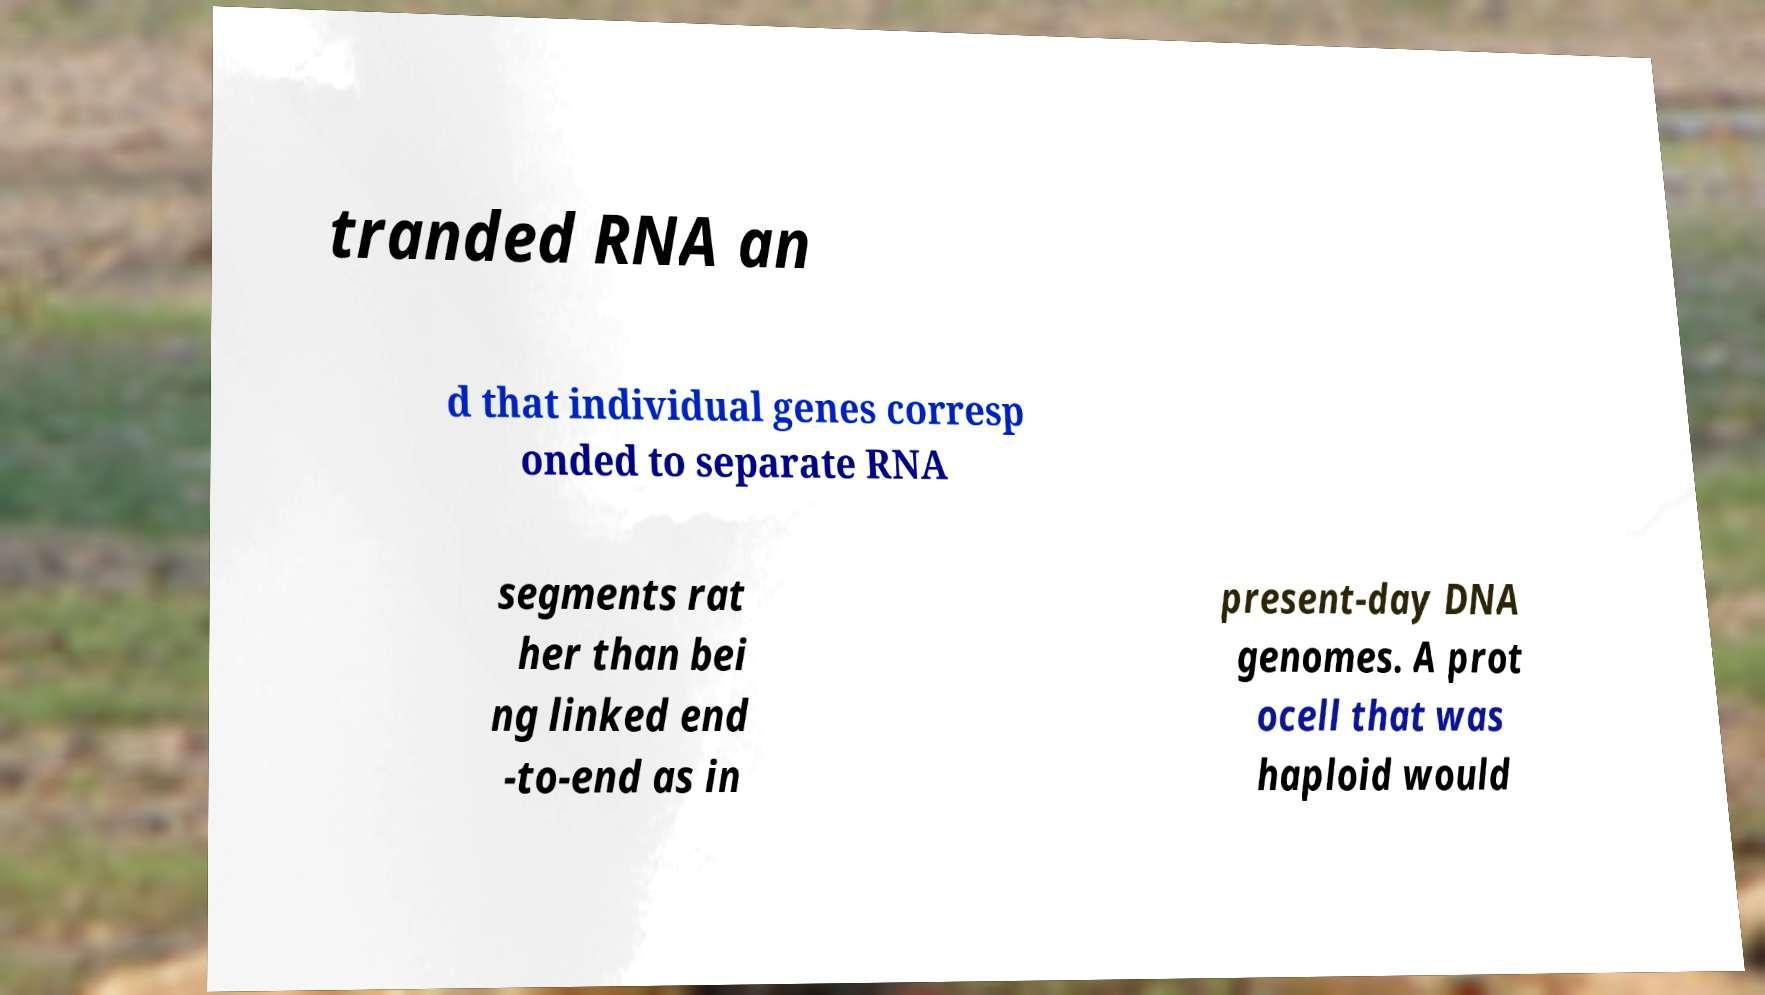Could you extract and type out the text from this image? tranded RNA an d that individual genes corresp onded to separate RNA segments rat her than bei ng linked end -to-end as in present-day DNA genomes. A prot ocell that was haploid would 